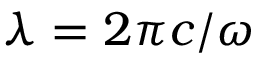<formula> <loc_0><loc_0><loc_500><loc_500>\lambda = 2 \pi c / \omega</formula> 